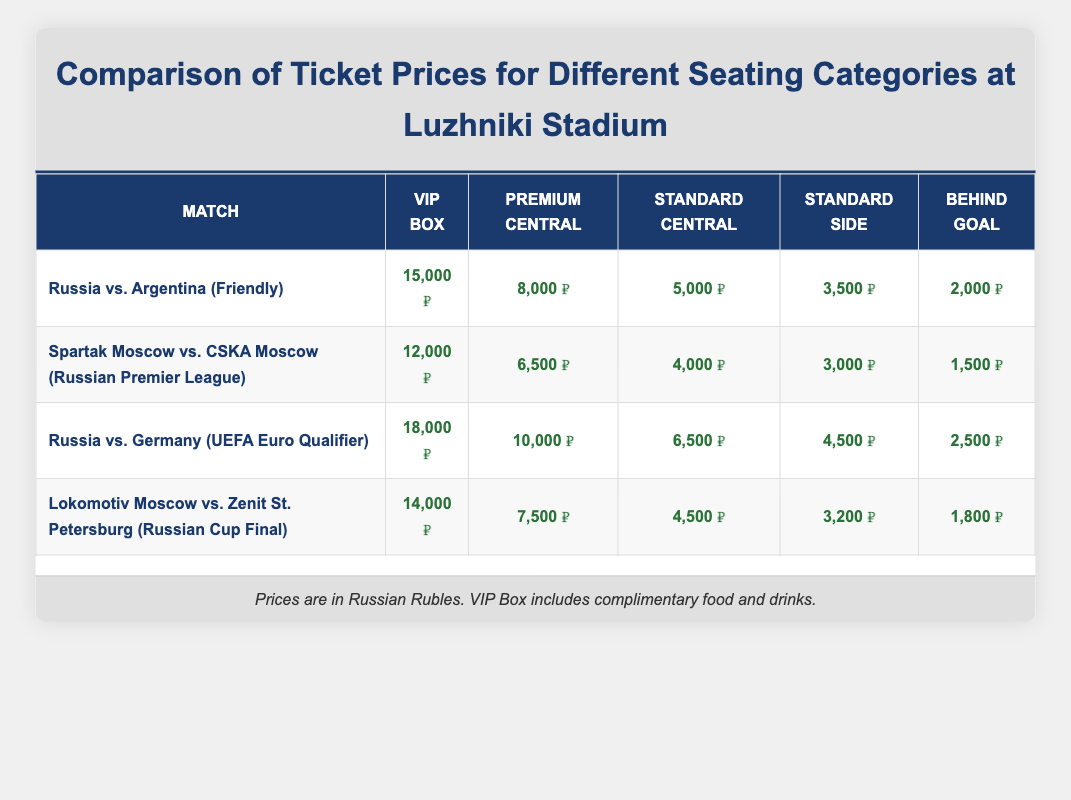What is the price of a VIP Box ticket for the match Russia vs. Germany? The table lists the price for a VIP Box ticket for the match "Russia vs. Germany (UEFA Euro Qualifier)" as 18,000 RUB.
Answer: 18,000 RUB What is the average price of tickets in the Standard Side category across all matches? To find the average price, we need the prices from the Standard Side category for all matches: 3,500, 3,000, 4,500, and 3,200. We calculate the sum: 3,500 + 3,000 + 4,500 + 3,200 = 14,200. Then, divide by the number of matches (4): 14,200 / 4 = 3,550.
Answer: 3,550 RUB Is the price of a Premium Central ticket for Spartak Moscow vs. CSKA Moscow more than 7,000 RUB? The price for the Premium Central ticket for this match is 6,500 RUB, which is less than 7,000 RUB. Therefore, the answer is no.
Answer: No What is the price difference between the Standard Central tickets for Russia vs. Argentina and Lokomotiv Moscow vs. Zenit St. Petersburg? The price for the Standard Central ticket for "Russia vs. Argentina" is 5,000 RUB, and for "Lokomotiv Moscow vs. Zenit St. Petersburg," it is 4,500 RUB. The difference is calculated as: 5,000 - 4,500 = 500 RUB.
Answer: 500 RUB Which match has the highest ticket price for the VIP Box category? Looking at the VIP Box prices for each match, we see they are: 15,000 (Russia vs. Argentina), 12,000 (Spartak Moscow vs. CSKA Moscow), 18,000 (Russia vs. Germany), and 14,000 (Lokomotiv Moscow vs. Zenit St. Petersburg). The highest price is 18,000 RUB for "Russia vs. Germany."
Answer: Russia vs. Germany What is the total price for all types of tickets for the match Russia vs. Argentina? The prices for all ticket types at the match "Russia vs. Argentina" are: 15,000 (VIP Box), 8,000 (Premium Central), 5,000 (Standard Central), 3,500 (Standard Side), and 2,000 (Behind Goal). We calculate the total as follows: 15,000 + 8,000 + 5,000 + 3,500 + 2,000 = 33,500 RUB.
Answer: 33,500 RUB Are the prices for the Behind Goal tickets consistent across all matches? The prices for Behind Goal tickets are: 2,000 (Russia vs. Argentina), 1,500 (Spartak Moscow vs. CSKA Moscow), 2,500 (Russia vs. Germany), and 1,800 (Lokomotiv Moscow vs. Zenit St. Petersburg). Since these prices vary, they are not consistent.
Answer: No What is the average price of a ticket in the VIP Box category? We take the prices of VIP Box tickets from all matches: 15,000, 12,000, 18,000, and 14,000. The sum is 15,000 + 12,000 + 18,000 + 14,000 = 59,000. We then divide by the four matches: 59,000 / 4 = 14,750 RUB.
Answer: 14,750 RUB 